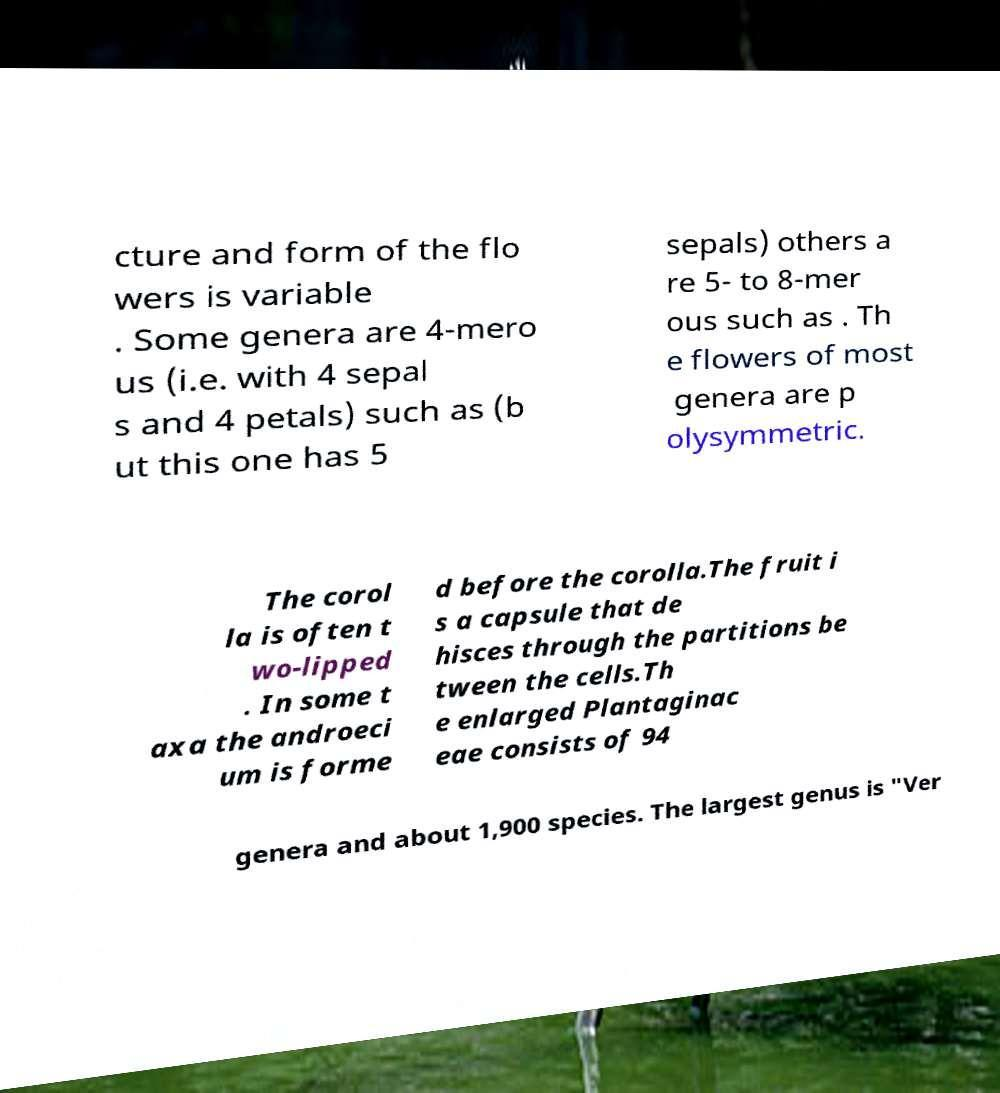There's text embedded in this image that I need extracted. Can you transcribe it verbatim? cture and form of the flo wers is variable . Some genera are 4-mero us (i.e. with 4 sepal s and 4 petals) such as (b ut this one has 5 sepals) others a re 5- to 8-mer ous such as . Th e flowers of most genera are p olysymmetric. The corol la is often t wo-lipped . In some t axa the androeci um is forme d before the corolla.The fruit i s a capsule that de hisces through the partitions be tween the cells.Th e enlarged Plantaginac eae consists of 94 genera and about 1,900 species. The largest genus is "Ver 